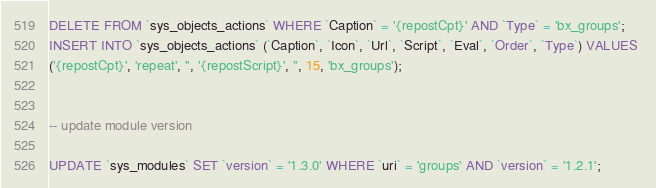Convert code to text. <code><loc_0><loc_0><loc_500><loc_500><_SQL_>

DELETE FROM `sys_objects_actions` WHERE `Caption` = '{repostCpt}' AND `Type` = 'bx_groups';
INSERT INTO `sys_objects_actions` (`Caption`, `Icon`, `Url`, `Script`, `Eval`, `Order`, `Type`) VALUES 
('{repostCpt}', 'repeat', '', '{repostScript}', '', 15, 'bx_groups');


-- update module version

UPDATE `sys_modules` SET `version` = '1.3.0' WHERE `uri` = 'groups' AND `version` = '1.2.1';

</code> 